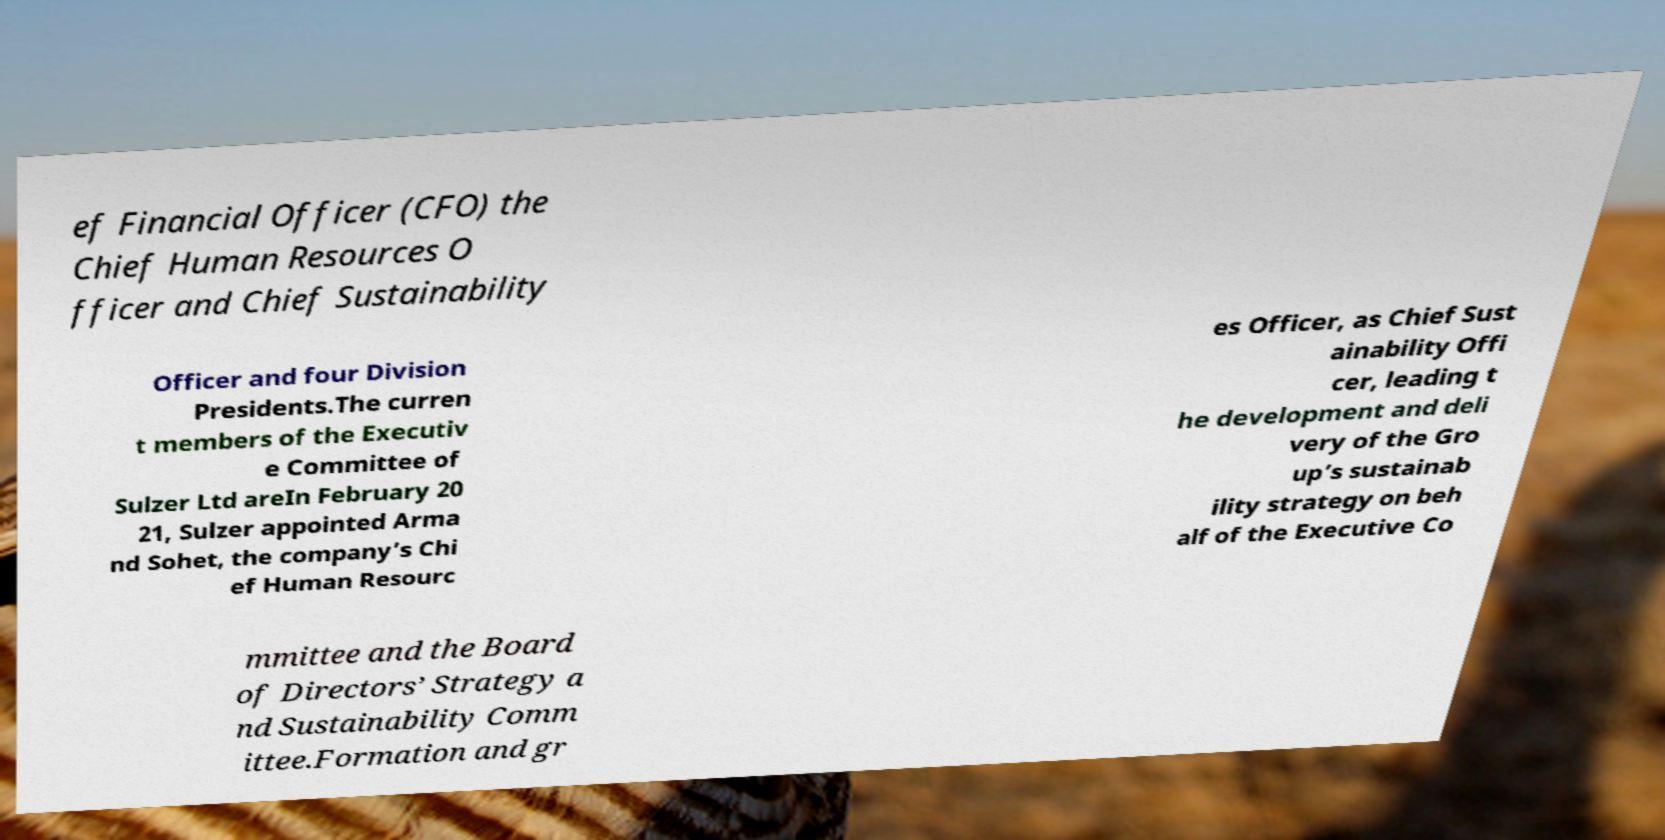I need the written content from this picture converted into text. Can you do that? ef Financial Officer (CFO) the Chief Human Resources O fficer and Chief Sustainability Officer and four Division Presidents.The curren t members of the Executiv e Committee of Sulzer Ltd areIn February 20 21, Sulzer appointed Arma nd Sohet, the company’s Chi ef Human Resourc es Officer, as Chief Sust ainability Offi cer, leading t he development and deli very of the Gro up’s sustainab ility strategy on beh alf of the Executive Co mmittee and the Board of Directors’ Strategy a nd Sustainability Comm ittee.Formation and gr 